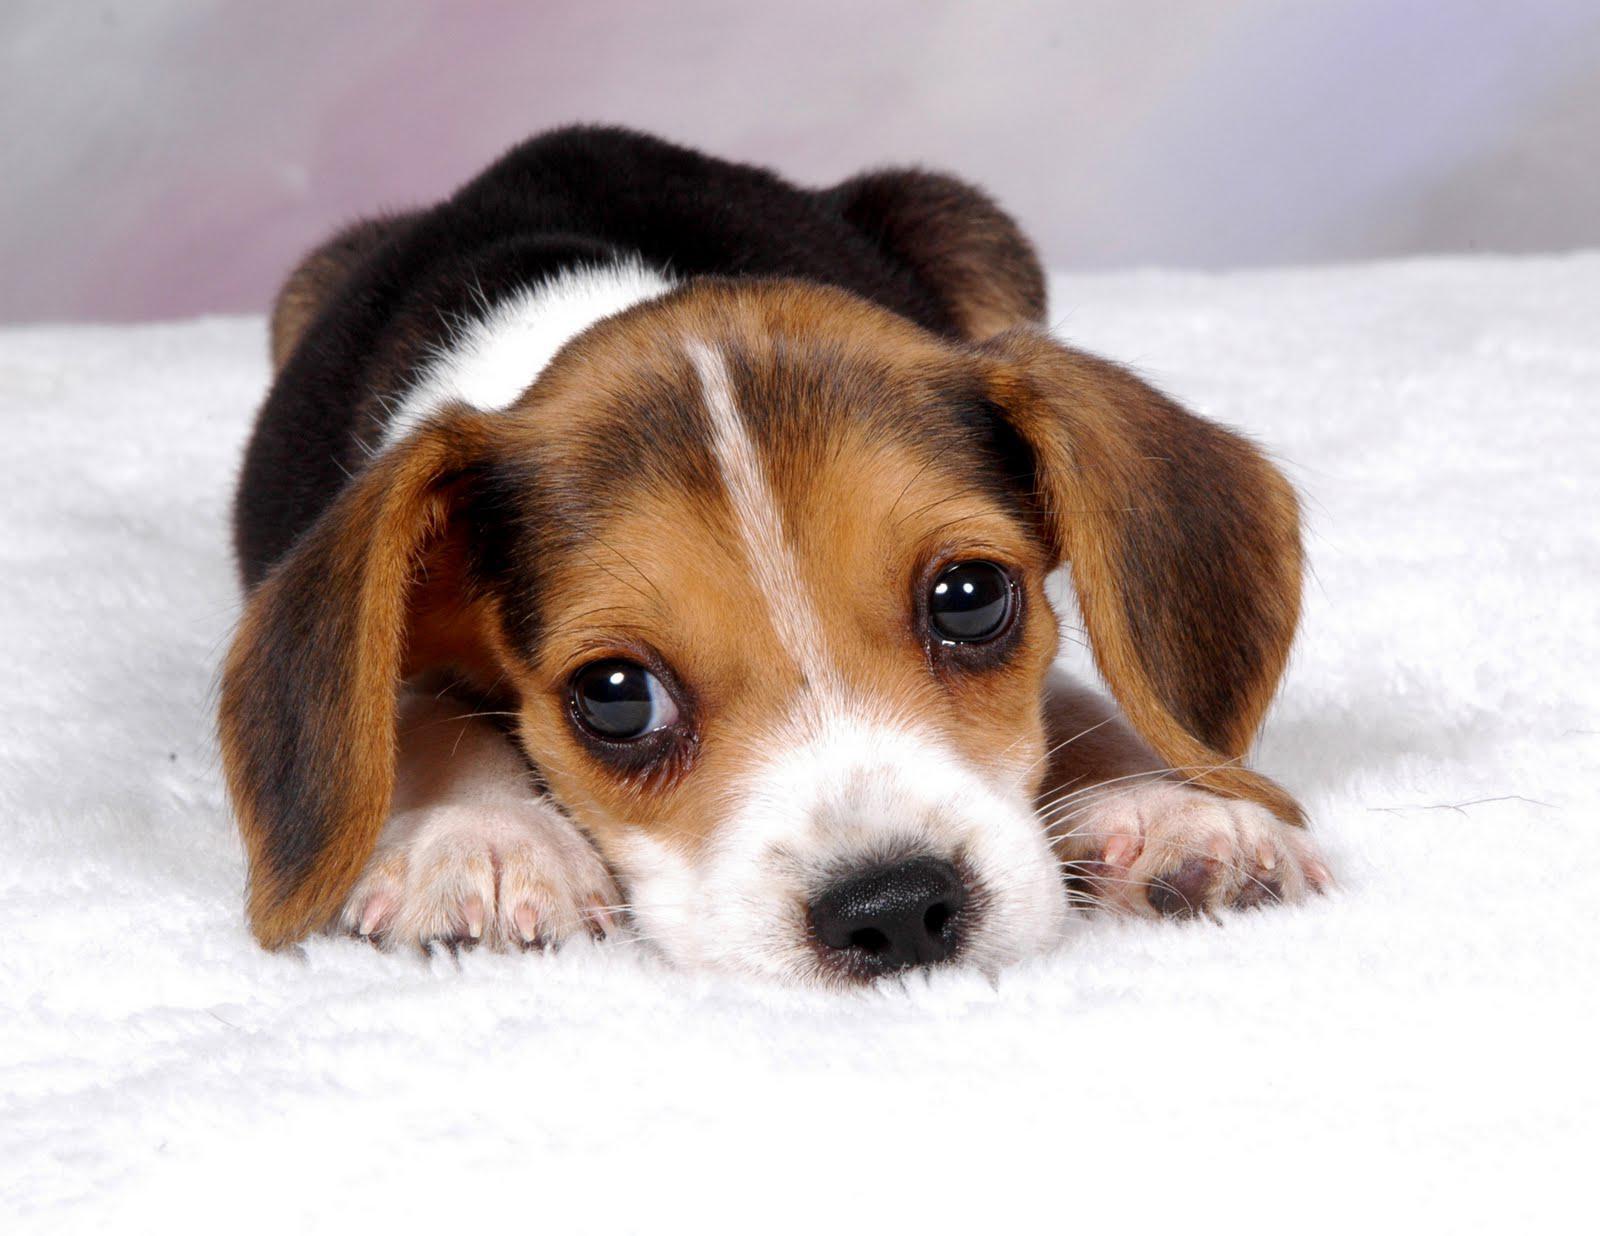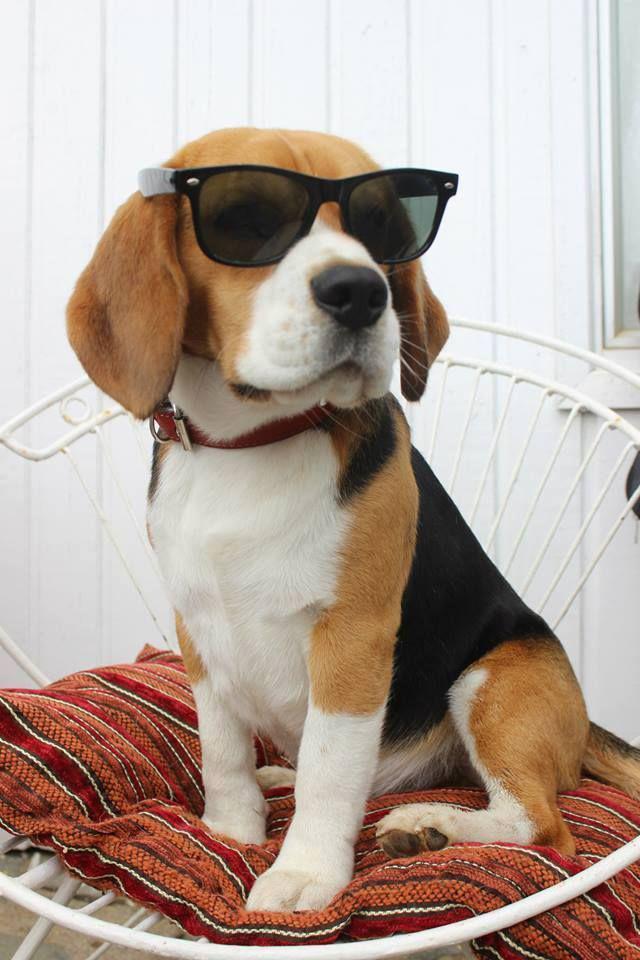The first image is the image on the left, the second image is the image on the right. Evaluate the accuracy of this statement regarding the images: "there is a beagle puppy lying belly down in the image to the left". Is it true? Answer yes or no. Yes. The first image is the image on the left, the second image is the image on the right. For the images displayed, is the sentence "The image on the right shows at least one beagle puppy held by a human hand." factually correct? Answer yes or no. No. 